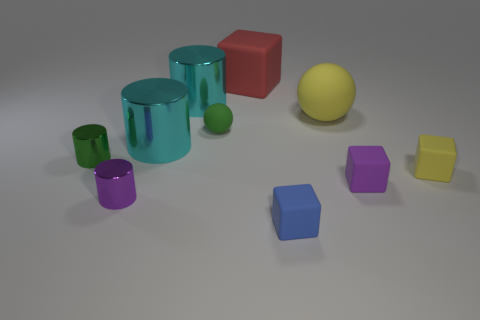What number of tiny matte objects are both on the left side of the blue block and right of the small green rubber ball?
Keep it short and to the point. 0. Is the shape of the tiny rubber thing that is in front of the purple cube the same as  the large yellow thing?
Provide a short and direct response. No. There is a green ball that is the same size as the blue thing; what is it made of?
Keep it short and to the point. Rubber. Are there the same number of green cylinders that are left of the green shiny object and matte cubes that are behind the yellow rubber cube?
Offer a terse response. No. There is a metallic cylinder that is on the left side of the small cylinder that is in front of the green metallic cylinder; how many yellow matte things are behind it?
Provide a succinct answer. 1. There is a large sphere; is it the same color as the shiny cylinder to the left of the purple cylinder?
Your answer should be compact. No. What size is the yellow cube that is the same material as the large yellow ball?
Give a very brief answer. Small. Are there more big cubes on the right side of the small yellow matte object than yellow objects?
Your answer should be compact. No. What material is the tiny purple object right of the tiny matte cube on the left side of the yellow rubber ball right of the purple metallic cylinder made of?
Give a very brief answer. Rubber. Is the small green cylinder made of the same material as the tiny purple thing that is right of the large sphere?
Offer a very short reply. No. 